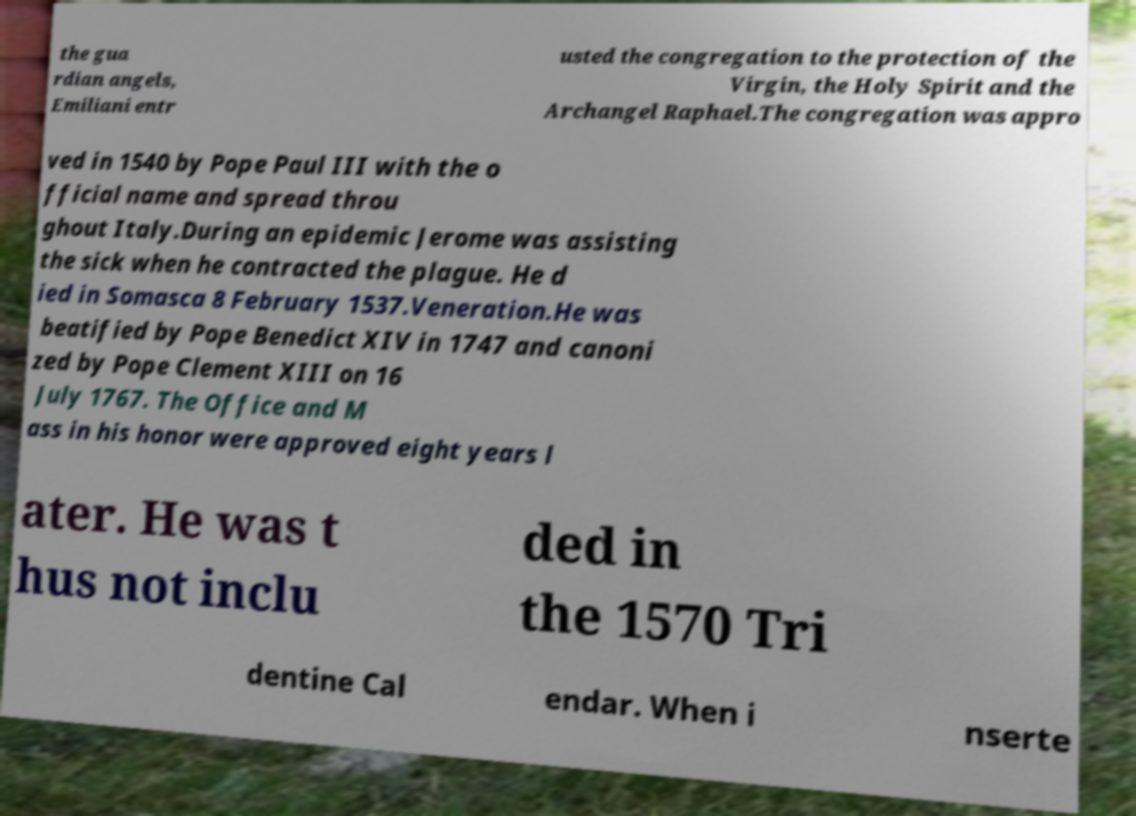There's text embedded in this image that I need extracted. Can you transcribe it verbatim? the gua rdian angels, Emiliani entr usted the congregation to the protection of the Virgin, the Holy Spirit and the Archangel Raphael.The congregation was appro ved in 1540 by Pope Paul III with the o fficial name and spread throu ghout Italy.During an epidemic Jerome was assisting the sick when he contracted the plague. He d ied in Somasca 8 February 1537.Veneration.He was beatified by Pope Benedict XIV in 1747 and canoni zed by Pope Clement XIII on 16 July 1767. The Office and M ass in his honor were approved eight years l ater. He was t hus not inclu ded in the 1570 Tri dentine Cal endar. When i nserte 